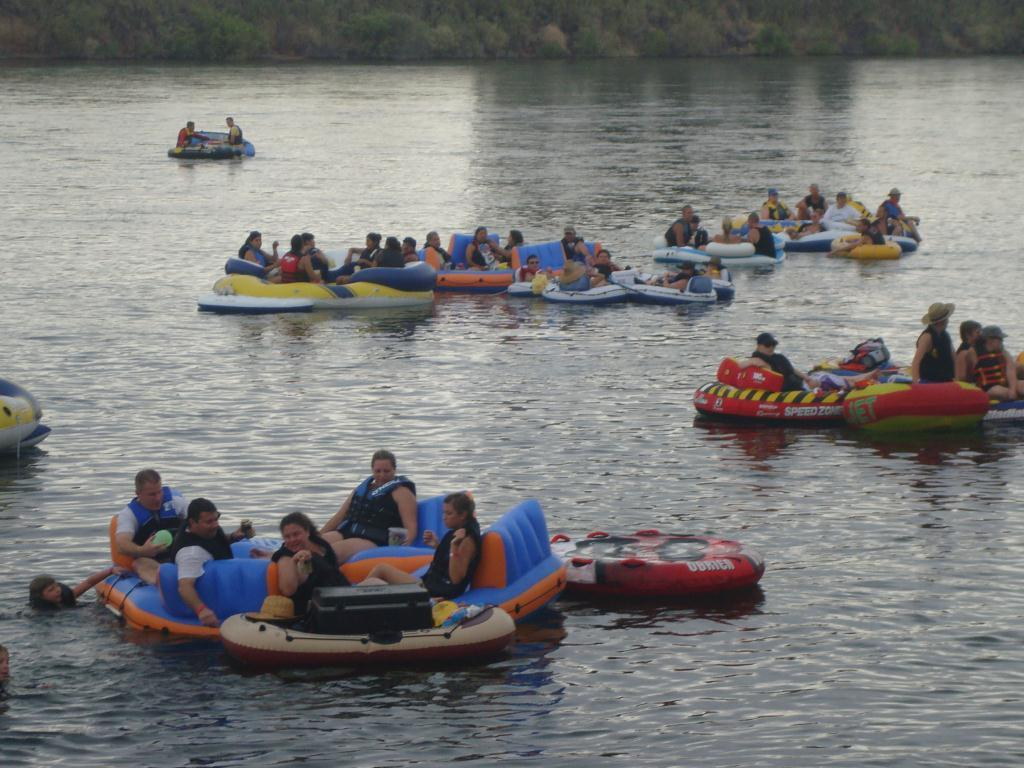What activity are the people in the image engaged in? The people in the image are sailing on a boat. Can you describe the person in the water? There is a person in the water, but their specific actions or appearance cannot be determined from the image. What else is on the water besides the boat? There are objects on the water, but their nature or purpose cannot be determined from the image. What type of vegetation is visible in the background of the image? There are plants visible in the background of the image. Can you see a cracker being eaten by a kitten on the boat in the image? There is no cracker or kitten present in the image. What type of tramp is visible in the background of the image? There is no tramp present in the image; it features people sailing on a boat, a person in the water, objects on the water, and plants in the background. 